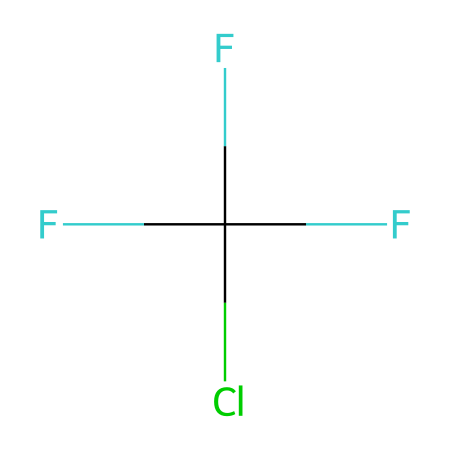What is the molecular formula of this freon gas? The molecular formula can be derived from counting all the atoms represented in the SMILES notation. The chemical consists of 1 fluorine atom (F), 1 chlorine atom (Cl), and 3 carbon atoms (C), with a total of 2 hydrogen atoms (H) resulting in the formula C2HClF3.
Answer: C2HClF3 How many carbon atoms are present in this molecule? By analyzing the SMILES notation, you can see that there are two 'C' characters, which indicate two carbon atoms in the structure.
Answer: 2 What type of gas is represented by this SMILES notation? Based on the presence of fluorine, chlorine, and carbon atoms in the structure, this is identified as a chlorofluorocarbon (CFC), a class of compounds known for their use in refrigeration and as propellants.
Answer: chlorofluorocarbon What effect does this compound have on the ozone layer? Chlorofluorocarbons are known to release chlorine atoms when they break down, which contribute to ozone layer depletion by catalyzing the breakdown of ozone molecules.
Answer: depletion How many total atoms are there in this molecular structure? By counting all the individual atoms represented in the SMILES notation, you identify 6 atoms in total: 2 carbon, 2 fluorine, 1 chlorine, and 1 hydrogen atom.
Answer: 6 Which element in this molecule is primarily responsible for ozone depletion? The chlorine atom in this molecule, when released into the atmosphere, contributes to the breakdown of ozone molecules, making it the primary element responsible for ozone depletion.
Answer: chlorine 